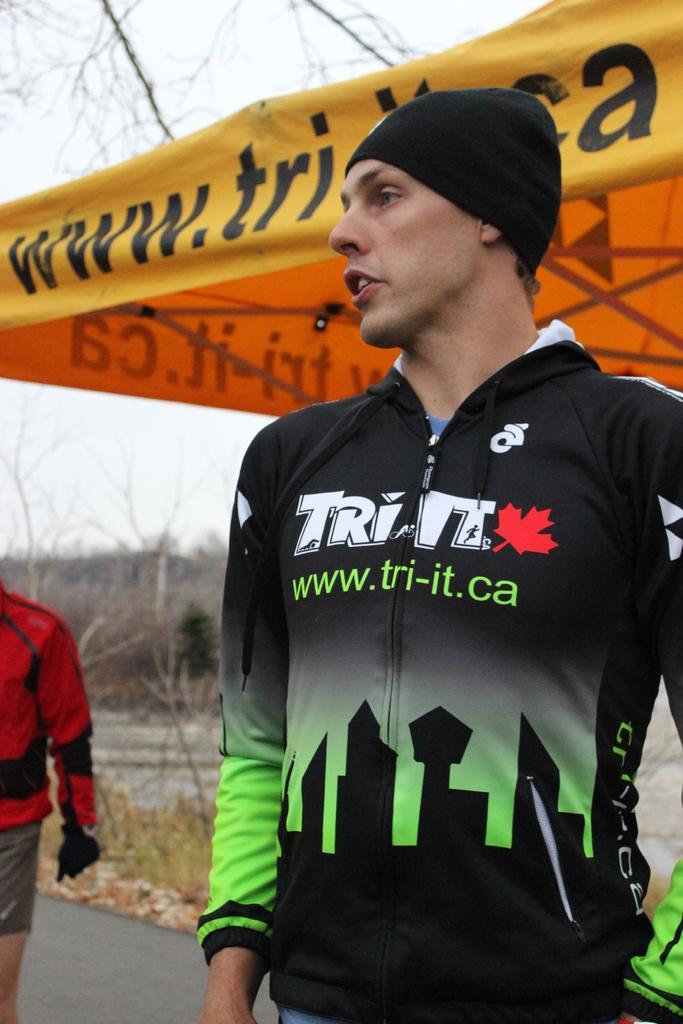Can you describe this image briefly? In this picture there is a person standing and wearing a black jacket and there is another person wearing red jacket in the left corner and there are some other objects in the background. 